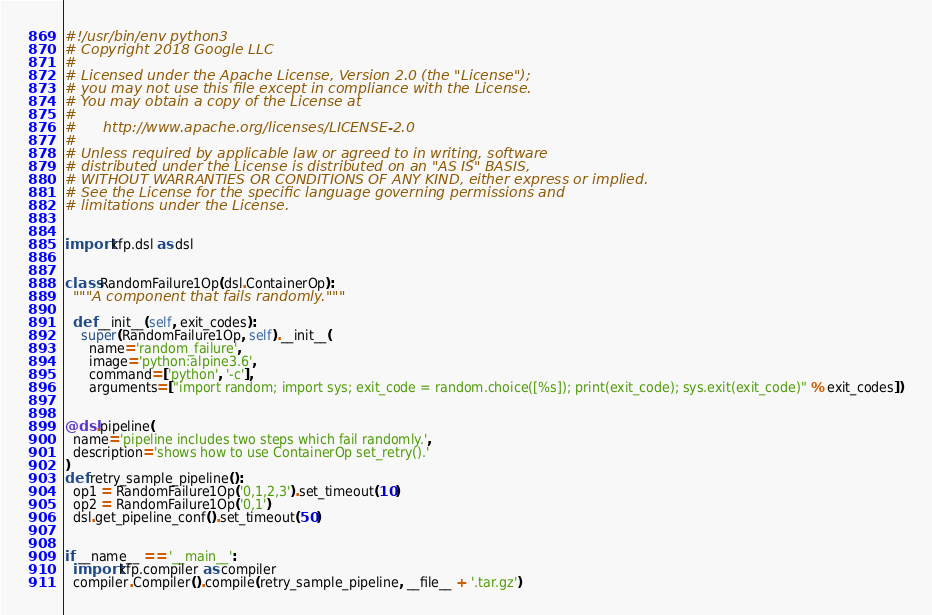Convert code to text. <code><loc_0><loc_0><loc_500><loc_500><_Python_>#!/usr/bin/env python3
# Copyright 2018 Google LLC
#
# Licensed under the Apache License, Version 2.0 (the "License");
# you may not use this file except in compliance with the License.
# You may obtain a copy of the License at
#
#      http://www.apache.org/licenses/LICENSE-2.0
#
# Unless required by applicable law or agreed to in writing, software
# distributed under the License is distributed on an "AS IS" BASIS,
# WITHOUT WARRANTIES OR CONDITIONS OF ANY KIND, either express or implied.
# See the License for the specific language governing permissions and
# limitations under the License.


import kfp.dsl as dsl


class RandomFailure1Op(dsl.ContainerOp):
  """A component that fails randomly."""

  def __init__(self, exit_codes):
    super(RandomFailure1Op, self).__init__(
      name='random_failure',
      image='python:alpine3.6',
      command=['python', '-c'],
      arguments=["import random; import sys; exit_code = random.choice([%s]); print(exit_code); sys.exit(exit_code)" % exit_codes])


@dsl.pipeline(
  name='pipeline includes two steps which fail randomly.',
  description='shows how to use ContainerOp set_retry().'
)
def retry_sample_pipeline():
  op1 = RandomFailure1Op('0,1,2,3').set_timeout(10)
  op2 = RandomFailure1Op('0,1')
  dsl.get_pipeline_conf().set_timeout(50)


if __name__ == '__main__':
  import kfp.compiler as compiler
  compiler.Compiler().compile(retry_sample_pipeline, __file__ + '.tar.gz')
</code> 